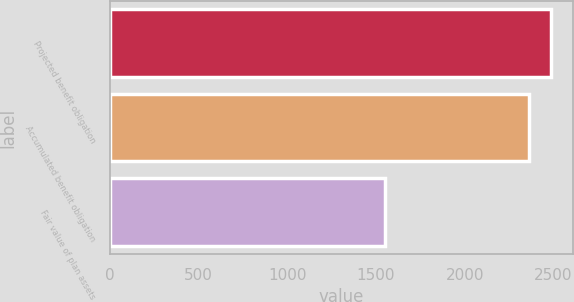Convert chart. <chart><loc_0><loc_0><loc_500><loc_500><bar_chart><fcel>Projected benefit obligation<fcel>Accumulated benefit obligation<fcel>Fair value of plan assets<nl><fcel>2488<fcel>2363<fcel>1552<nl></chart> 